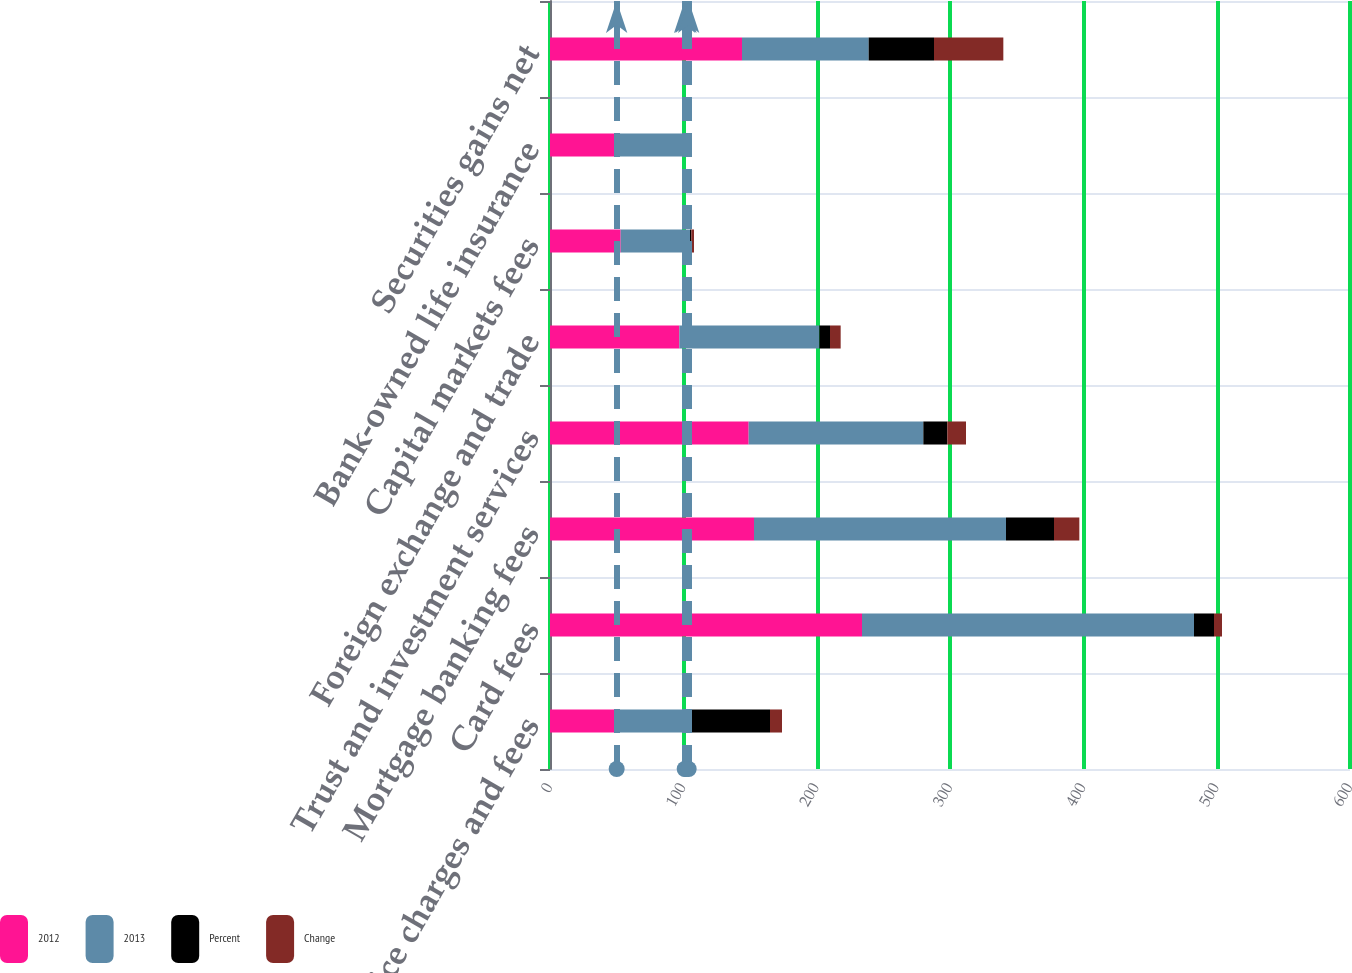Convert chart. <chart><loc_0><loc_0><loc_500><loc_500><stacked_bar_chart><ecel><fcel>Service charges and fees<fcel>Card fees<fcel>Mortgage banking fees<fcel>Trust and investment services<fcel>Foreign exchange and trade<fcel>Capital markets fees<fcel>Bank-owned life insurance<fcel>Securities gains net<nl><fcel>2012<fcel>50.5<fcel>234<fcel>153<fcel>149<fcel>97<fcel>53<fcel>50<fcel>144<nl><fcel>2013<fcel>50.5<fcel>249<fcel>189<fcel>131<fcel>105<fcel>52<fcel>51<fcel>95<nl><fcel>Percent<fcel>64<fcel>15<fcel>36<fcel>18<fcel>8<fcel>1<fcel>1<fcel>49<nl><fcel>Change<fcel>9<fcel>6<fcel>19<fcel>14<fcel>8<fcel>2<fcel>2<fcel>52<nl></chart> 